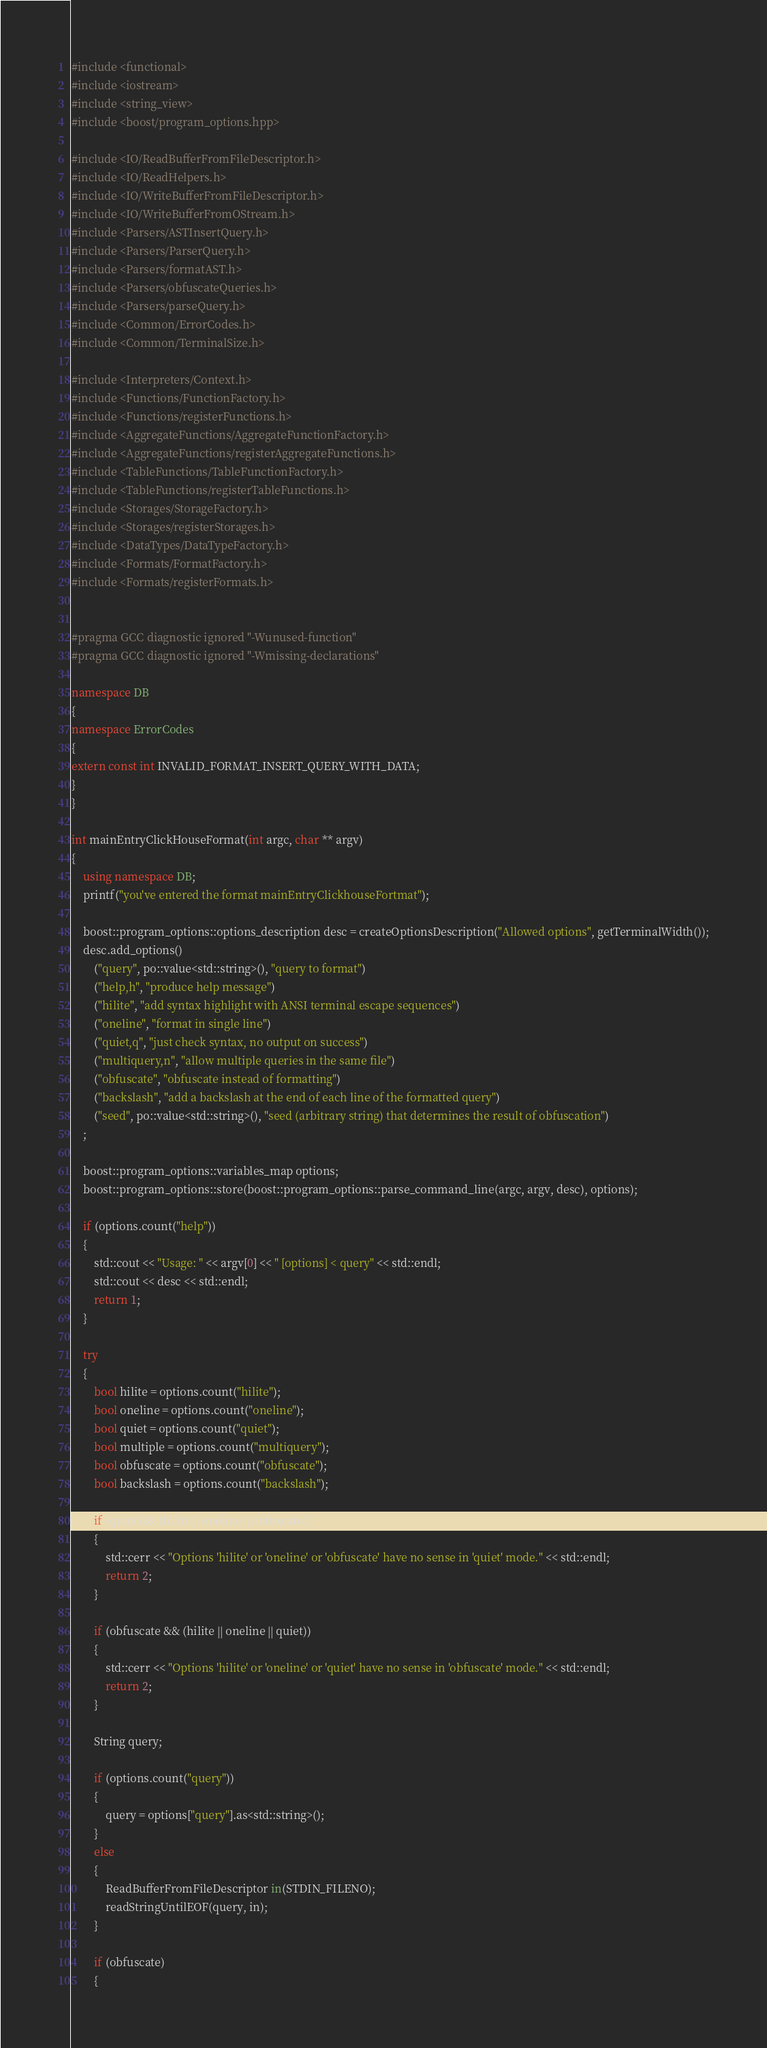Convert code to text. <code><loc_0><loc_0><loc_500><loc_500><_C++_>#include <functional>
#include <iostream>
#include <string_view>
#include <boost/program_options.hpp>

#include <IO/ReadBufferFromFileDescriptor.h>
#include <IO/ReadHelpers.h>
#include <IO/WriteBufferFromFileDescriptor.h>
#include <IO/WriteBufferFromOStream.h>
#include <Parsers/ASTInsertQuery.h>
#include <Parsers/ParserQuery.h>
#include <Parsers/formatAST.h>
#include <Parsers/obfuscateQueries.h>
#include <Parsers/parseQuery.h>
#include <Common/ErrorCodes.h>
#include <Common/TerminalSize.h>

#include <Interpreters/Context.h>
#include <Functions/FunctionFactory.h>
#include <Functions/registerFunctions.h>
#include <AggregateFunctions/AggregateFunctionFactory.h>
#include <AggregateFunctions/registerAggregateFunctions.h>
#include <TableFunctions/TableFunctionFactory.h>
#include <TableFunctions/registerTableFunctions.h>
#include <Storages/StorageFactory.h>
#include <Storages/registerStorages.h>
#include <DataTypes/DataTypeFactory.h>
#include <Formats/FormatFactory.h>
#include <Formats/registerFormats.h>


#pragma GCC diagnostic ignored "-Wunused-function"
#pragma GCC diagnostic ignored "-Wmissing-declarations"

namespace DB
{
namespace ErrorCodes
{
extern const int INVALID_FORMAT_INSERT_QUERY_WITH_DATA;
}
}

int mainEntryClickHouseFormat(int argc, char ** argv)
{
    using namespace DB;
    printf("you've entered the format mainEntryClickhouseFortmat");

    boost::program_options::options_description desc = createOptionsDescription("Allowed options", getTerminalWidth());
    desc.add_options()
        ("query", po::value<std::string>(), "query to format")
        ("help,h", "produce help message")
        ("hilite", "add syntax highlight with ANSI terminal escape sequences")
        ("oneline", "format in single line")
        ("quiet,q", "just check syntax, no output on success")
        ("multiquery,n", "allow multiple queries in the same file")
        ("obfuscate", "obfuscate instead of formatting")
        ("backslash", "add a backslash at the end of each line of the formatted query")
        ("seed", po::value<std::string>(), "seed (arbitrary string) that determines the result of obfuscation")
    ;

    boost::program_options::variables_map options;
    boost::program_options::store(boost::program_options::parse_command_line(argc, argv, desc), options);

    if (options.count("help"))
    {
        std::cout << "Usage: " << argv[0] << " [options] < query" << std::endl;
        std::cout << desc << std::endl;
        return 1;
    }

    try
    {
        bool hilite = options.count("hilite");
        bool oneline = options.count("oneline");
        bool quiet = options.count("quiet");
        bool multiple = options.count("multiquery");
        bool obfuscate = options.count("obfuscate");
        bool backslash = options.count("backslash");

        if (quiet && (hilite || oneline || obfuscate))
        {
            std::cerr << "Options 'hilite' or 'oneline' or 'obfuscate' have no sense in 'quiet' mode." << std::endl;
            return 2;
        }

        if (obfuscate && (hilite || oneline || quiet))
        {
            std::cerr << "Options 'hilite' or 'oneline' or 'quiet' have no sense in 'obfuscate' mode." << std::endl;
            return 2;
        }

        String query;

        if (options.count("query"))
        {
            query = options["query"].as<std::string>();
        }
        else
        {
            ReadBufferFromFileDescriptor in(STDIN_FILENO);
            readStringUntilEOF(query, in);
        }

        if (obfuscate)
        {</code> 